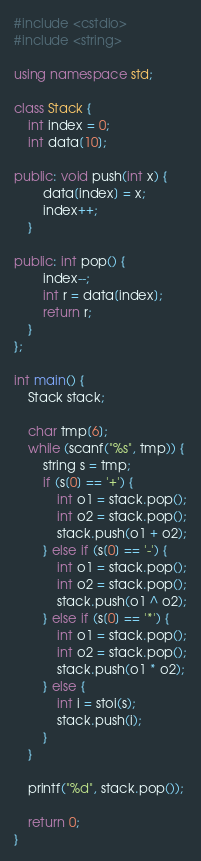<code> <loc_0><loc_0><loc_500><loc_500><_C++_>#include <cstdio>
#include <string>

using namespace std;

class Stack {
    int index = 0;
    int data[10];

public: void push(int x) {
        data[index] = x;
        index++;
    }

public: int pop() {
        index--;
        int r = data[index];
        return r;
    }
};

int main() {
    Stack stack;

    char tmp[6];
    while (scanf("%s", tmp)) {
        string s = tmp;
        if (s[0] == '+') {
            int o1 = stack.pop();
            int o2 = stack.pop();
            stack.push(o1 + o2);
        } else if (s[0] == '-') {
            int o1 = stack.pop();
            int o2 = stack.pop();
            stack.push(o1 ^ o2);
        } else if (s[0] == '*') {
            int o1 = stack.pop();
            int o2 = stack.pop();
            stack.push(o1 * o2);
        } else {
            int i = stoi(s);
            stack.push(i);
        }
    }

    printf("%d", stack.pop());

    return 0;
}</code> 